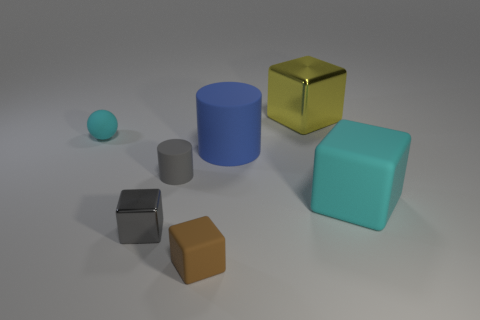Add 3 tiny purple cylinders. How many objects exist? 10 Subtract all big rubber cubes. How many cubes are left? 3 Subtract 1 balls. How many balls are left? 0 Subtract all blue cylinders. How many cylinders are left? 1 Subtract all green cubes. Subtract all brown balls. How many cubes are left? 4 Subtract all small gray objects. Subtract all tiny cyan spheres. How many objects are left? 4 Add 6 large yellow metallic blocks. How many large yellow metallic blocks are left? 7 Add 7 big rubber spheres. How many big rubber spheres exist? 7 Subtract 0 brown spheres. How many objects are left? 7 Subtract all spheres. How many objects are left? 6 